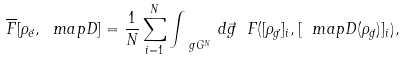<formula> <loc_0><loc_0><loc_500><loc_500>\overline { F } [ \rho _ { \vec { e } } , \ m a p { D } ] = \frac { 1 } { N } \sum _ { i = 1 } ^ { N } \int _ { \ g G ^ { N } } \, d { \vec { g } } \ F ( [ \rho _ { \vec { g } } ] _ { i } , [ \ m a p { D } ( \rho _ { \vec { g } } ) ] _ { i } ) ,</formula> 